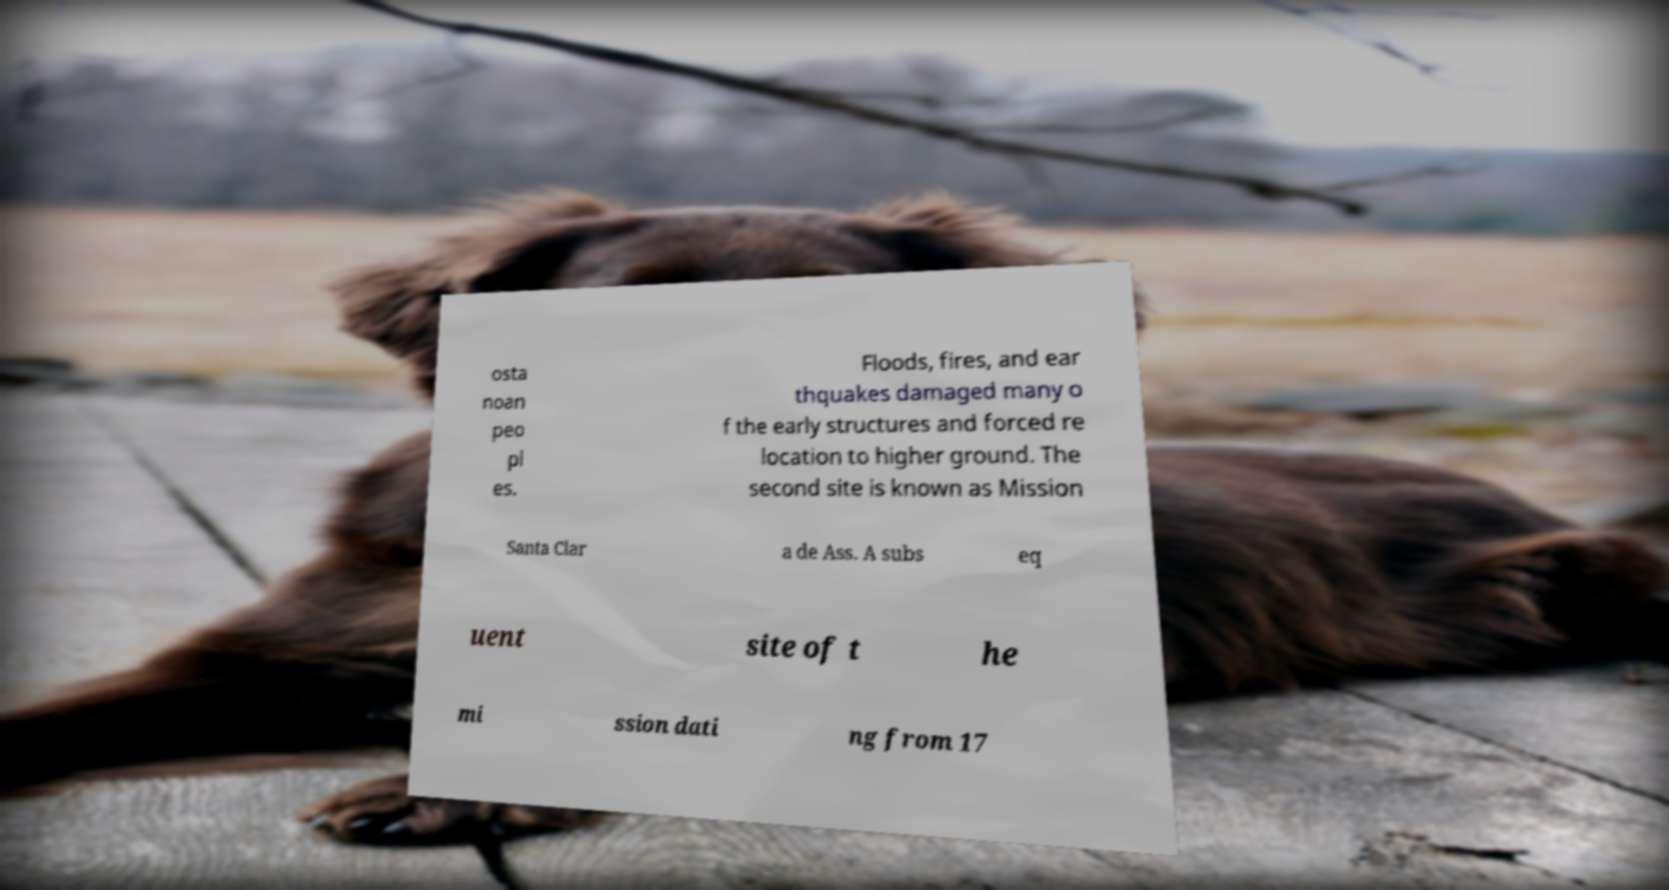What messages or text are displayed in this image? I need them in a readable, typed format. osta noan peo pl es. Floods, fires, and ear thquakes damaged many o f the early structures and forced re location to higher ground. The second site is known as Mission Santa Clar a de Ass. A subs eq uent site of t he mi ssion dati ng from 17 